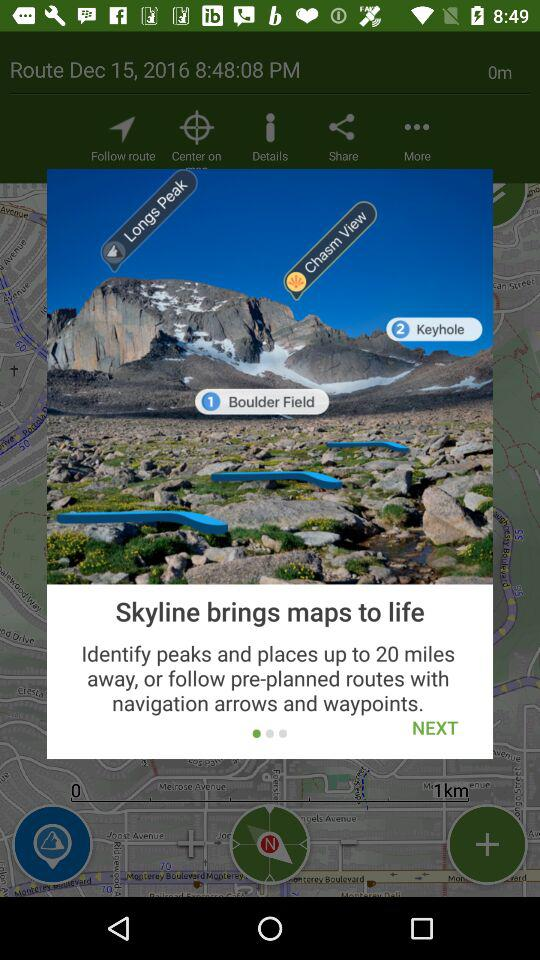How far are the peaks and places?
When the provided information is insufficient, respond with <no answer>. <no answer> 